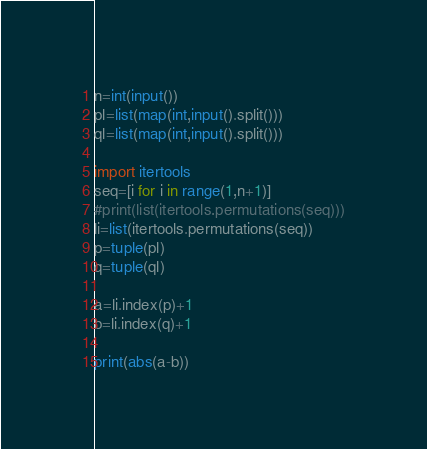<code> <loc_0><loc_0><loc_500><loc_500><_Python_>n=int(input())
pl=list(map(int,input().split()))
ql=list(map(int,input().split()))

import itertools
seq=[i for i in range(1,n+1)]
#print(list(itertools.permutations(seq)))
li=list(itertools.permutations(seq))
p=tuple(pl)
q=tuple(ql)

a=li.index(p)+1
b=li.index(q)+1

print(abs(a-b))</code> 